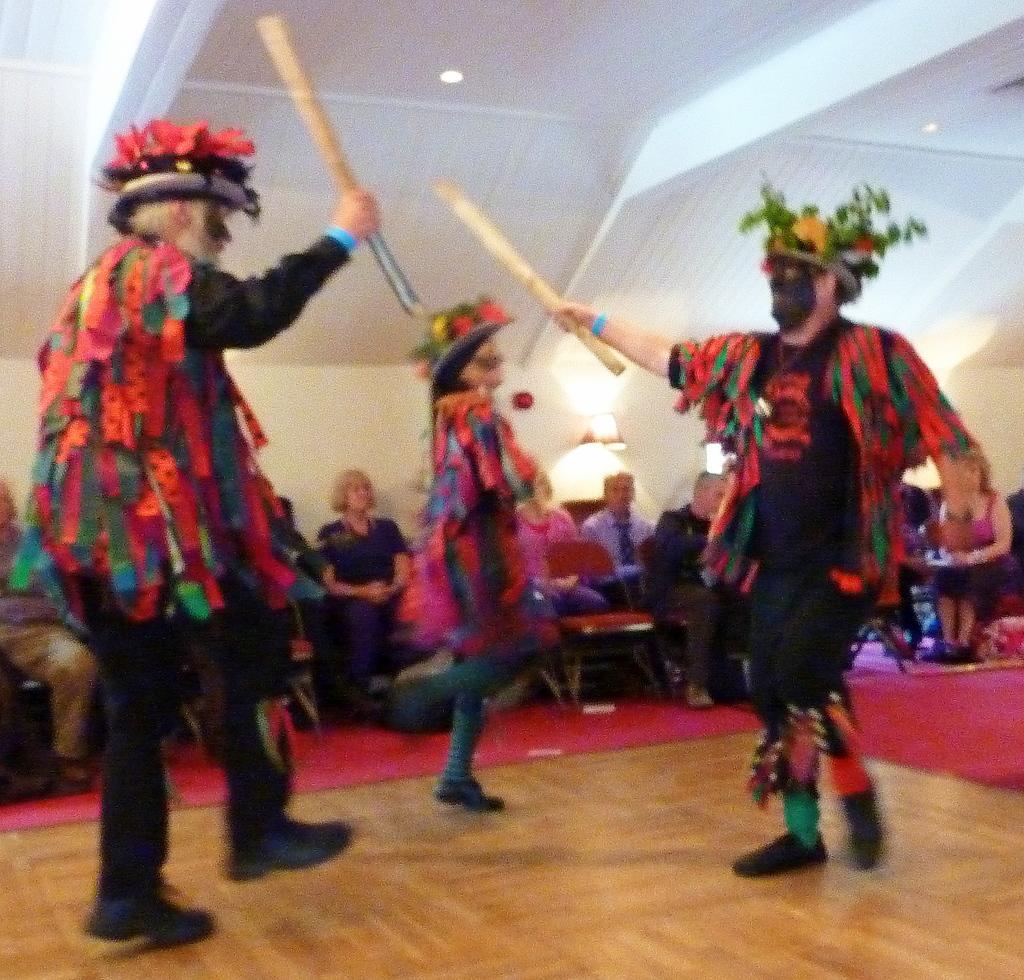In one or two sentences, can you explain what this image depicts? In this image there are three people performing a cultural dance by holding sticks in their hands, around them there are a few spectators watching them by seated on chairs. 